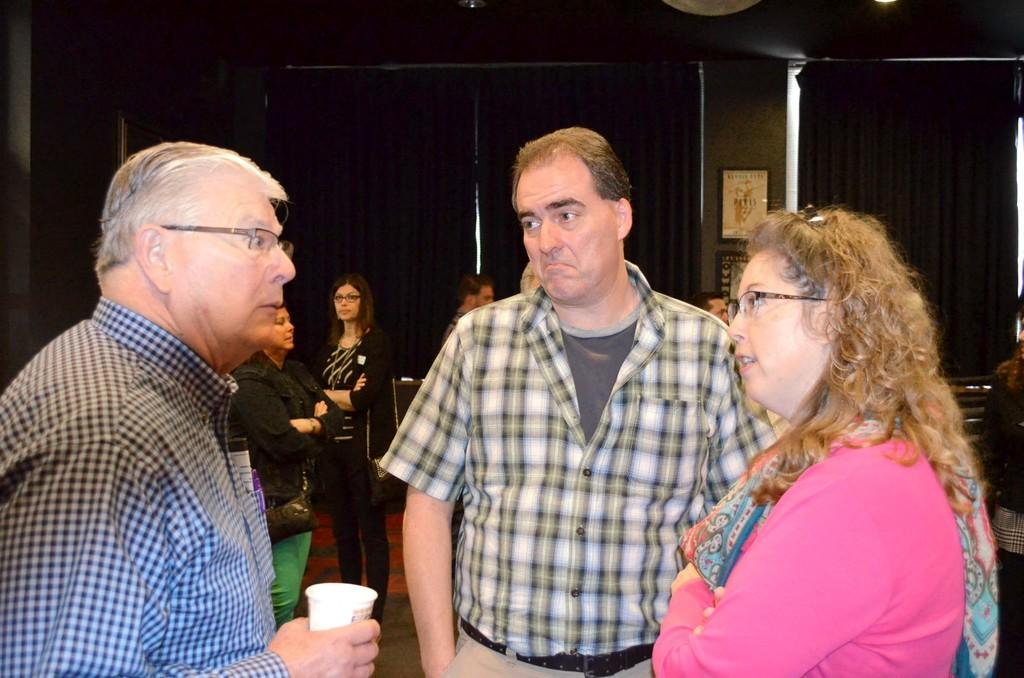How many people are in the image? There are three persons in the image. What is one of the persons doing with their hand? One of the persons is holding a cup with their hand. What can be seen in the background of the image? There are curtains, a pillar, frames, people, and other objects in the background of the image. What type of parcel is being used as bait in the image? There is no parcel or bait present in the image. What type of table is visible in the image? There is no table visible in the image. 